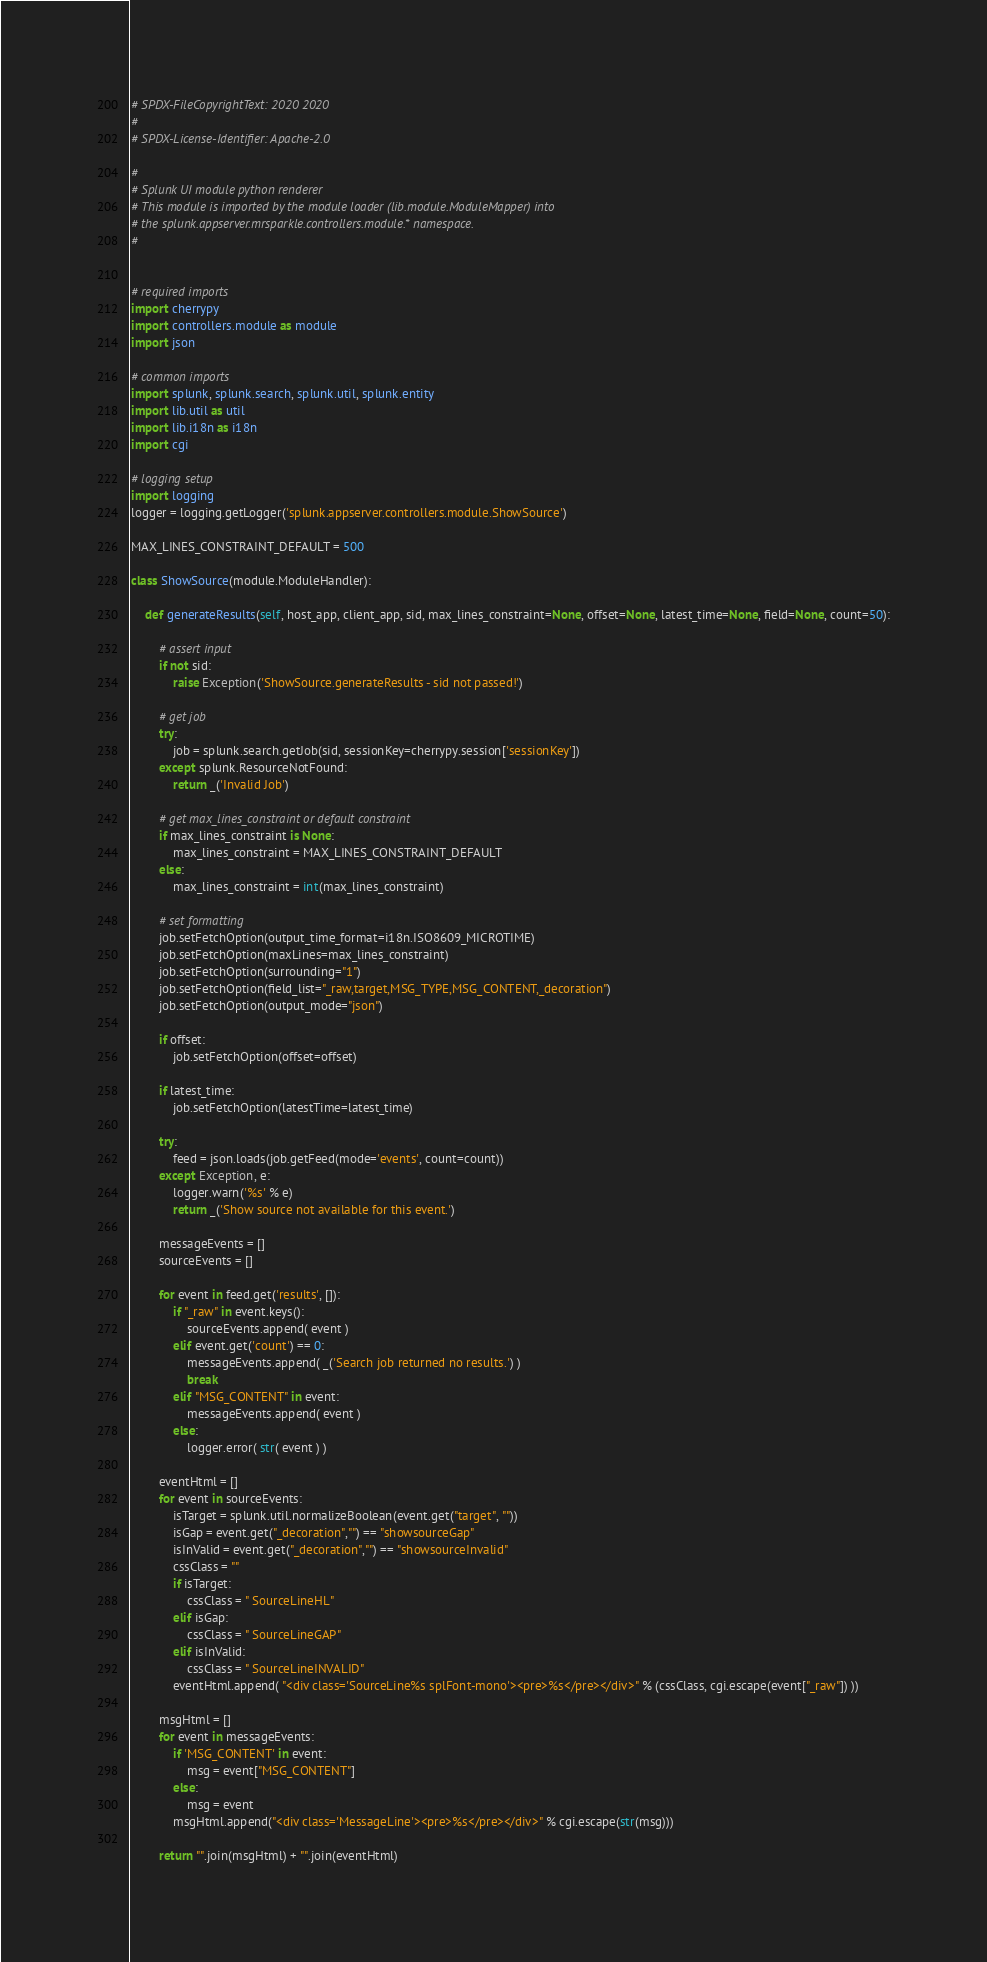<code> <loc_0><loc_0><loc_500><loc_500><_Python_># SPDX-FileCopyrightText: 2020 2020
#
# SPDX-License-Identifier: Apache-2.0

#
# Splunk UI module python renderer
# This module is imported by the module loader (lib.module.ModuleMapper) into
# the splunk.appserver.mrsparkle.controllers.module.* namespace.
#


# required imports
import cherrypy
import controllers.module as module
import json

# common imports
import splunk, splunk.search, splunk.util, splunk.entity
import lib.util as util
import lib.i18n as i18n
import cgi

# logging setup
import logging
logger = logging.getLogger('splunk.appserver.controllers.module.ShowSource')

MAX_LINES_CONSTRAINT_DEFAULT = 500

class ShowSource(module.ModuleHandler):
    
    def generateResults(self, host_app, client_app, sid, max_lines_constraint=None, offset=None, latest_time=None, field=None, count=50):
    
        # assert input
        if not sid:
            raise Exception('ShowSource.generateResults - sid not passed!')
            
        # get job
        try:
            job = splunk.search.getJob(sid, sessionKey=cherrypy.session['sessionKey'])
        except splunk.ResourceNotFound:
            return _('Invalid Job')
            
        # get max_lines_constraint or default constraint
        if max_lines_constraint is None:
            max_lines_constraint = MAX_LINES_CONSTRAINT_DEFAULT
        else:
            max_lines_constraint = int(max_lines_constraint)
        
        # set formatting
        job.setFetchOption(output_time_format=i18n.ISO8609_MICROTIME)
        job.setFetchOption(maxLines=max_lines_constraint)
        job.setFetchOption(surrounding="1")
        job.setFetchOption(field_list="_raw,target,MSG_TYPE,MSG_CONTENT,_decoration")
        job.setFetchOption(output_mode="json")

        if offset:
            job.setFetchOption(offset=offset)

        if latest_time:
            job.setFetchOption(latestTime=latest_time)

        try:
            feed = json.loads(job.getFeed(mode='events', count=count))
        except Exception, e:
            logger.warn('%s' % e)
            return _('Show source not available for this event.')

        messageEvents = []
        sourceEvents = []
        
        for event in feed.get('results', []):
            if "_raw" in event.keys():
                sourceEvents.append( event )
            elif event.get('count') == 0:
                messageEvents.append( _('Search job returned no results.') )
                break
            elif "MSG_CONTENT" in event:
                messageEvents.append( event )
            else:
                logger.error( str( event ) )

        eventHtml = []
        for event in sourceEvents:
            isTarget = splunk.util.normalizeBoolean(event.get("target", ""))
            isGap = event.get("_decoration","") == "showsourceGap"
            isInValid = event.get("_decoration","") == "showsourceInvalid"
            cssClass = ""
            if isTarget:
                cssClass = " SourceLineHL"
            elif isGap:
                cssClass = " SourceLineGAP"
            elif isInValid:
                cssClass = " SourceLineINVALID"
            eventHtml.append( "<div class='SourceLine%s splFont-mono'><pre>%s</pre></div>" % (cssClass, cgi.escape(event["_raw"]) ))
            
        msgHtml = []
        for event in messageEvents:
            if 'MSG_CONTENT' in event:
                msg = event["MSG_CONTENT"]
            else:
                msg = event
            msgHtml.append("<div class='MessageLine'><pre>%s</pre></div>" % cgi.escape(str(msg)))
            
        return "".join(msgHtml) + "".join(eventHtml)</code> 